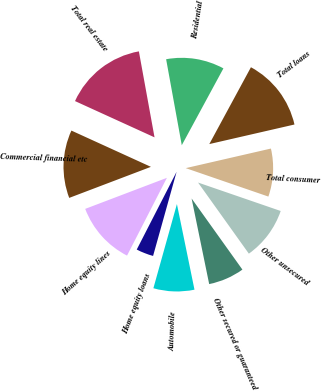Convert chart. <chart><loc_0><loc_0><loc_500><loc_500><pie_chart><fcel>Residential<fcel>Total real estate<fcel>Commercial financial etc<fcel>Home equity lines<fcel>Home equity loans<fcel>Automobile<fcel>Other secured or guaranteed<fcel>Other unsecured<fcel>Total consumer<fcel>Total loans<nl><fcel>10.77%<fcel>15.32%<fcel>12.59%<fcel>11.68%<fcel>3.2%<fcel>7.56%<fcel>6.65%<fcel>9.85%<fcel>8.87%<fcel>13.5%<nl></chart> 